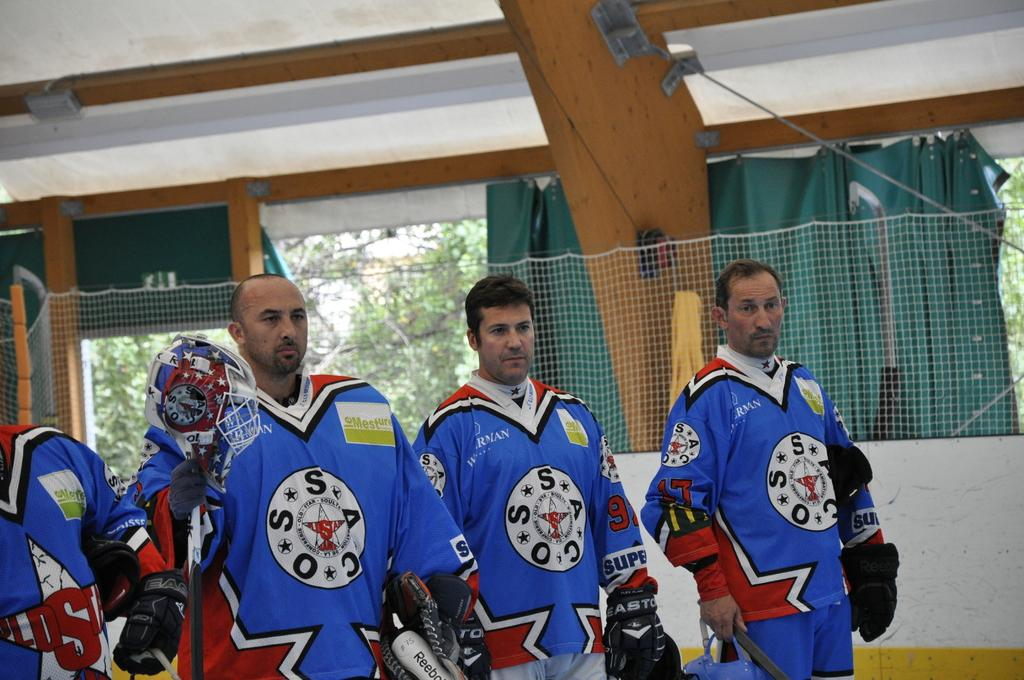Provide a one-sentence caption for the provided image. Four members of the OSSC hockey team in blue. 